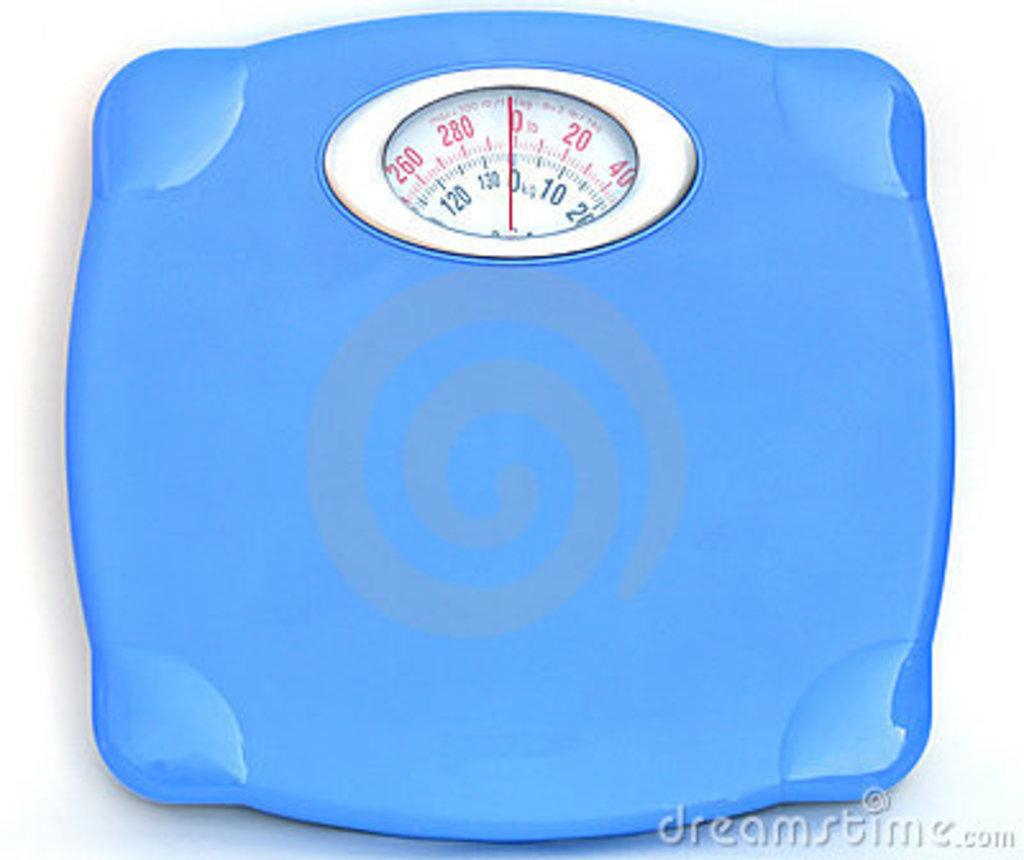What type of machine is visible in the image? There is a body weighing machine in the image. Can you describe any additional features of the image? There is a watermark on the picture. How many chickens are standing in line in the image? There are no chickens present in the image. What type of step is visible in the image? There is no step visible in the image. 